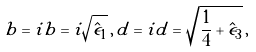<formula> <loc_0><loc_0><loc_500><loc_500>b = i \tilde { b } = i \sqrt { \hat { \epsilon } _ { 1 } } \, , \, d = i \tilde { d } = \sqrt { \frac { 1 } { 4 } + \hat { \epsilon } _ { 3 } } \, ,</formula> 